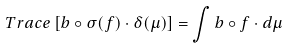<formula> <loc_0><loc_0><loc_500><loc_500>T r a c e \left [ b \circ \sigma ( f ) \cdot \delta ( \mu ) \right ] = \int b \circ f \cdot d \mu</formula> 